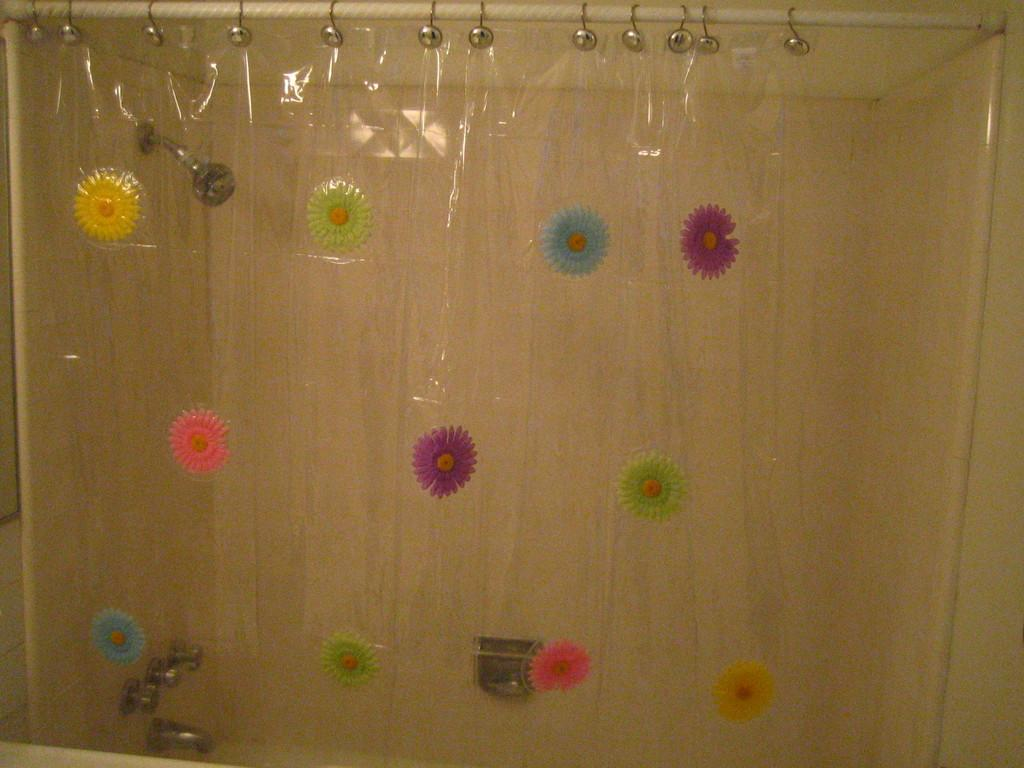What is the main subject in the center of the image? There is a curtain in the center of the image. Can you describe the curtain's appearance? The curtain is partially transparent or translucent. What can be seen through the curtain? A wall, a shower head, and a tap can be seen through the curtain. Are there any other objects visible through the curtain? Yes, there are some objects visible through the curtain, but their specific nature is not mentioned in the transcript. What is the weight of the wooden land visible through the curtain? There is no wooden land visible through the curtain, and therefore, its weight cannot be determined. 